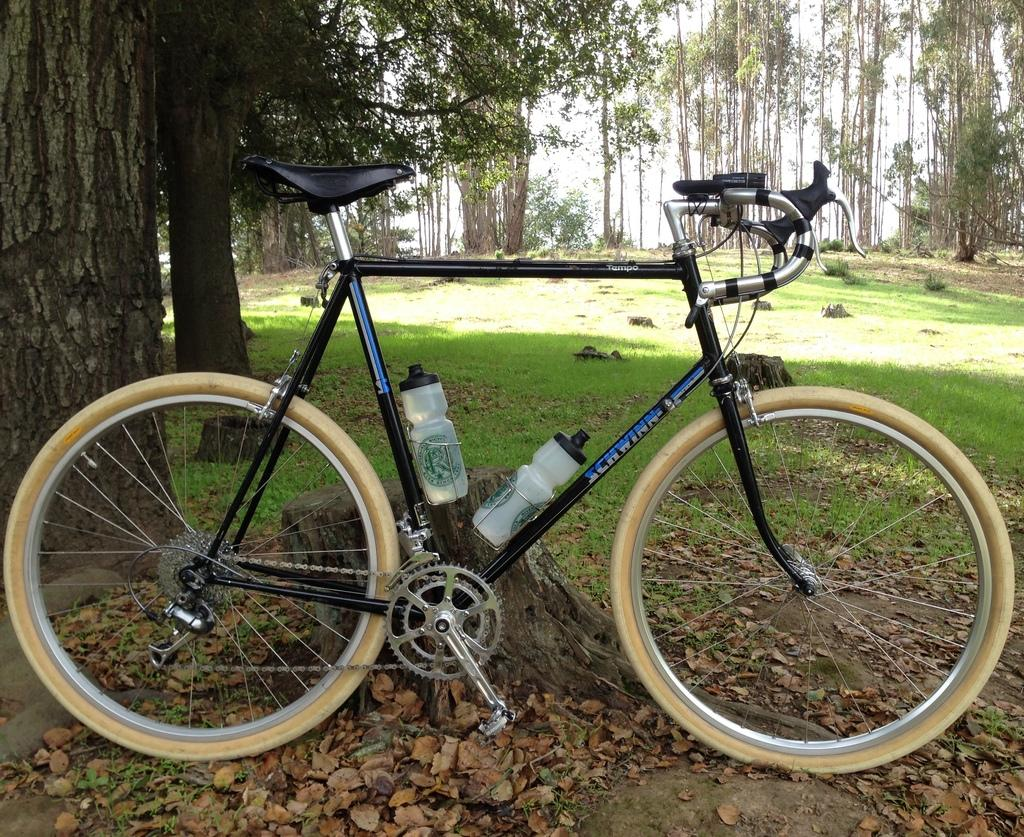What is the main object in the image? There is a bicycle in the image. What additional items are attached to the bicycle? The bicycle has two water bottles. What type of natural environment is depicted in the image? There are leaves, grass, and trees visible in the image. What type of disease is being reported in the news in the image? There is no news or disease mentioned in the image; it features a bicycle with two water bottles and a natural environment. 